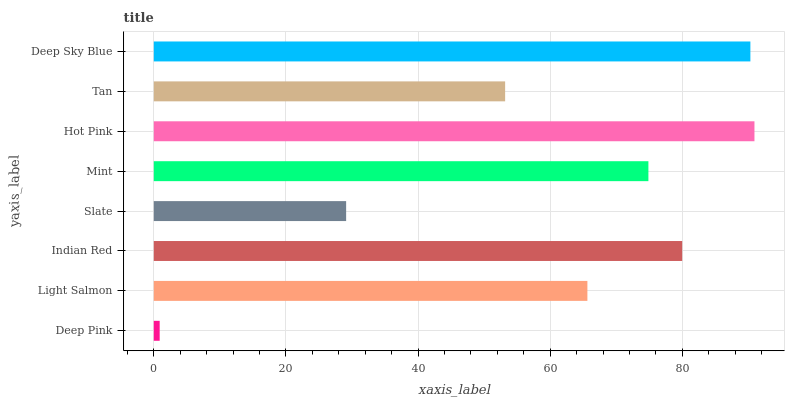Is Deep Pink the minimum?
Answer yes or no. Yes. Is Hot Pink the maximum?
Answer yes or no. Yes. Is Light Salmon the minimum?
Answer yes or no. No. Is Light Salmon the maximum?
Answer yes or no. No. Is Light Salmon greater than Deep Pink?
Answer yes or no. Yes. Is Deep Pink less than Light Salmon?
Answer yes or no. Yes. Is Deep Pink greater than Light Salmon?
Answer yes or no. No. Is Light Salmon less than Deep Pink?
Answer yes or no. No. Is Mint the high median?
Answer yes or no. Yes. Is Light Salmon the low median?
Answer yes or no. Yes. Is Hot Pink the high median?
Answer yes or no. No. Is Indian Red the low median?
Answer yes or no. No. 